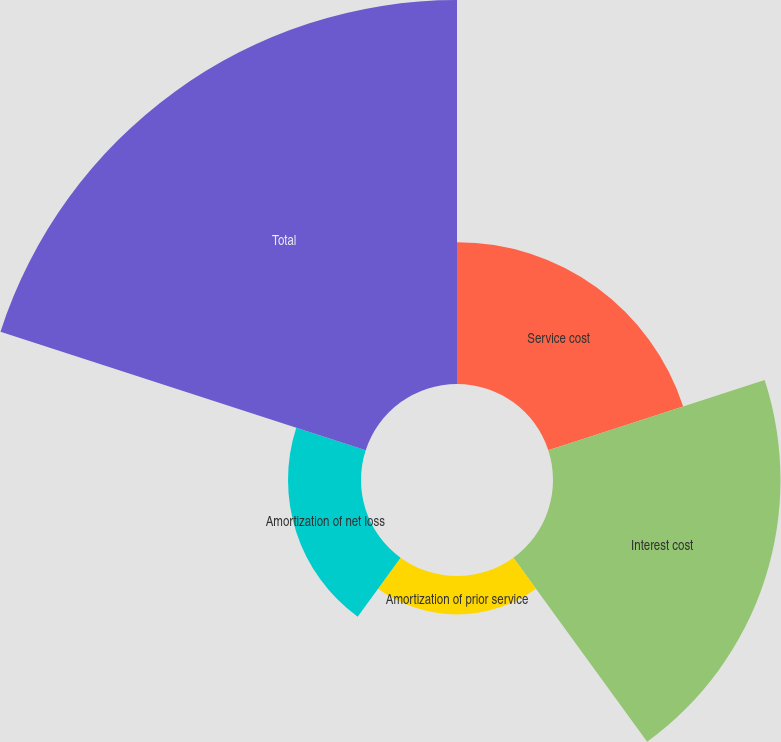Convert chart to OTSL. <chart><loc_0><loc_0><loc_500><loc_500><pie_chart><fcel>Service cost<fcel>Interest cost<fcel>Amortization of prior service<fcel>Amortization of net loss<fcel>Total<nl><fcel>16.4%<fcel>26.31%<fcel>4.44%<fcel>8.44%<fcel>44.41%<nl></chart> 